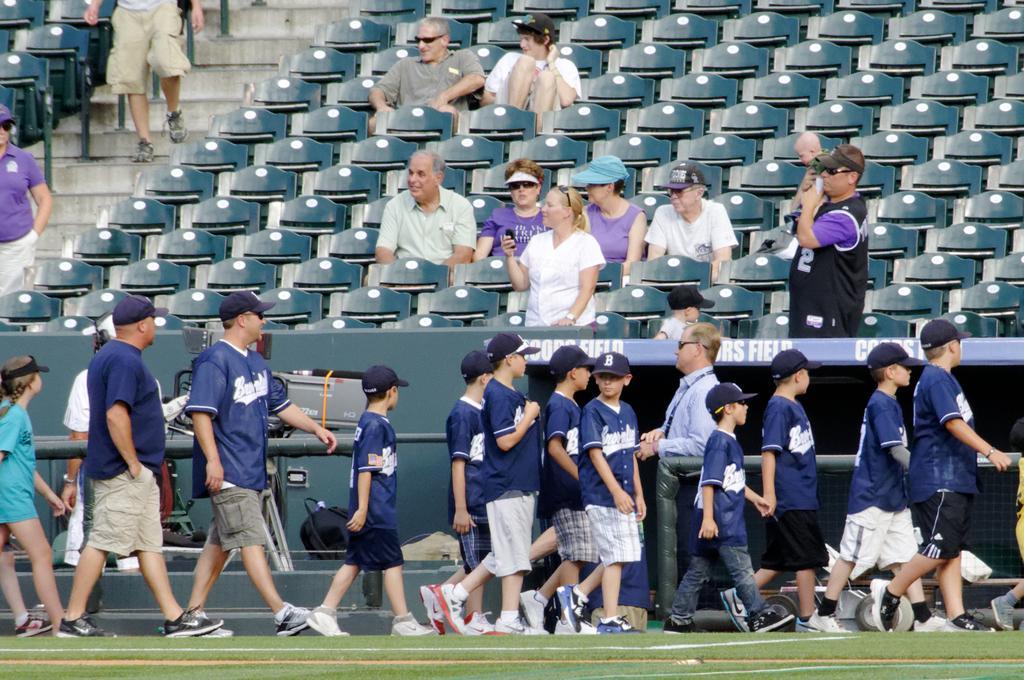Could you give a brief overview of what you see in this image? At the top of the image we can see some persons sitting on the chairs and some are climbing stairs. At the bottom of the image we can see persons walking on the ground. In the background we can see backpacks and iron rods. 